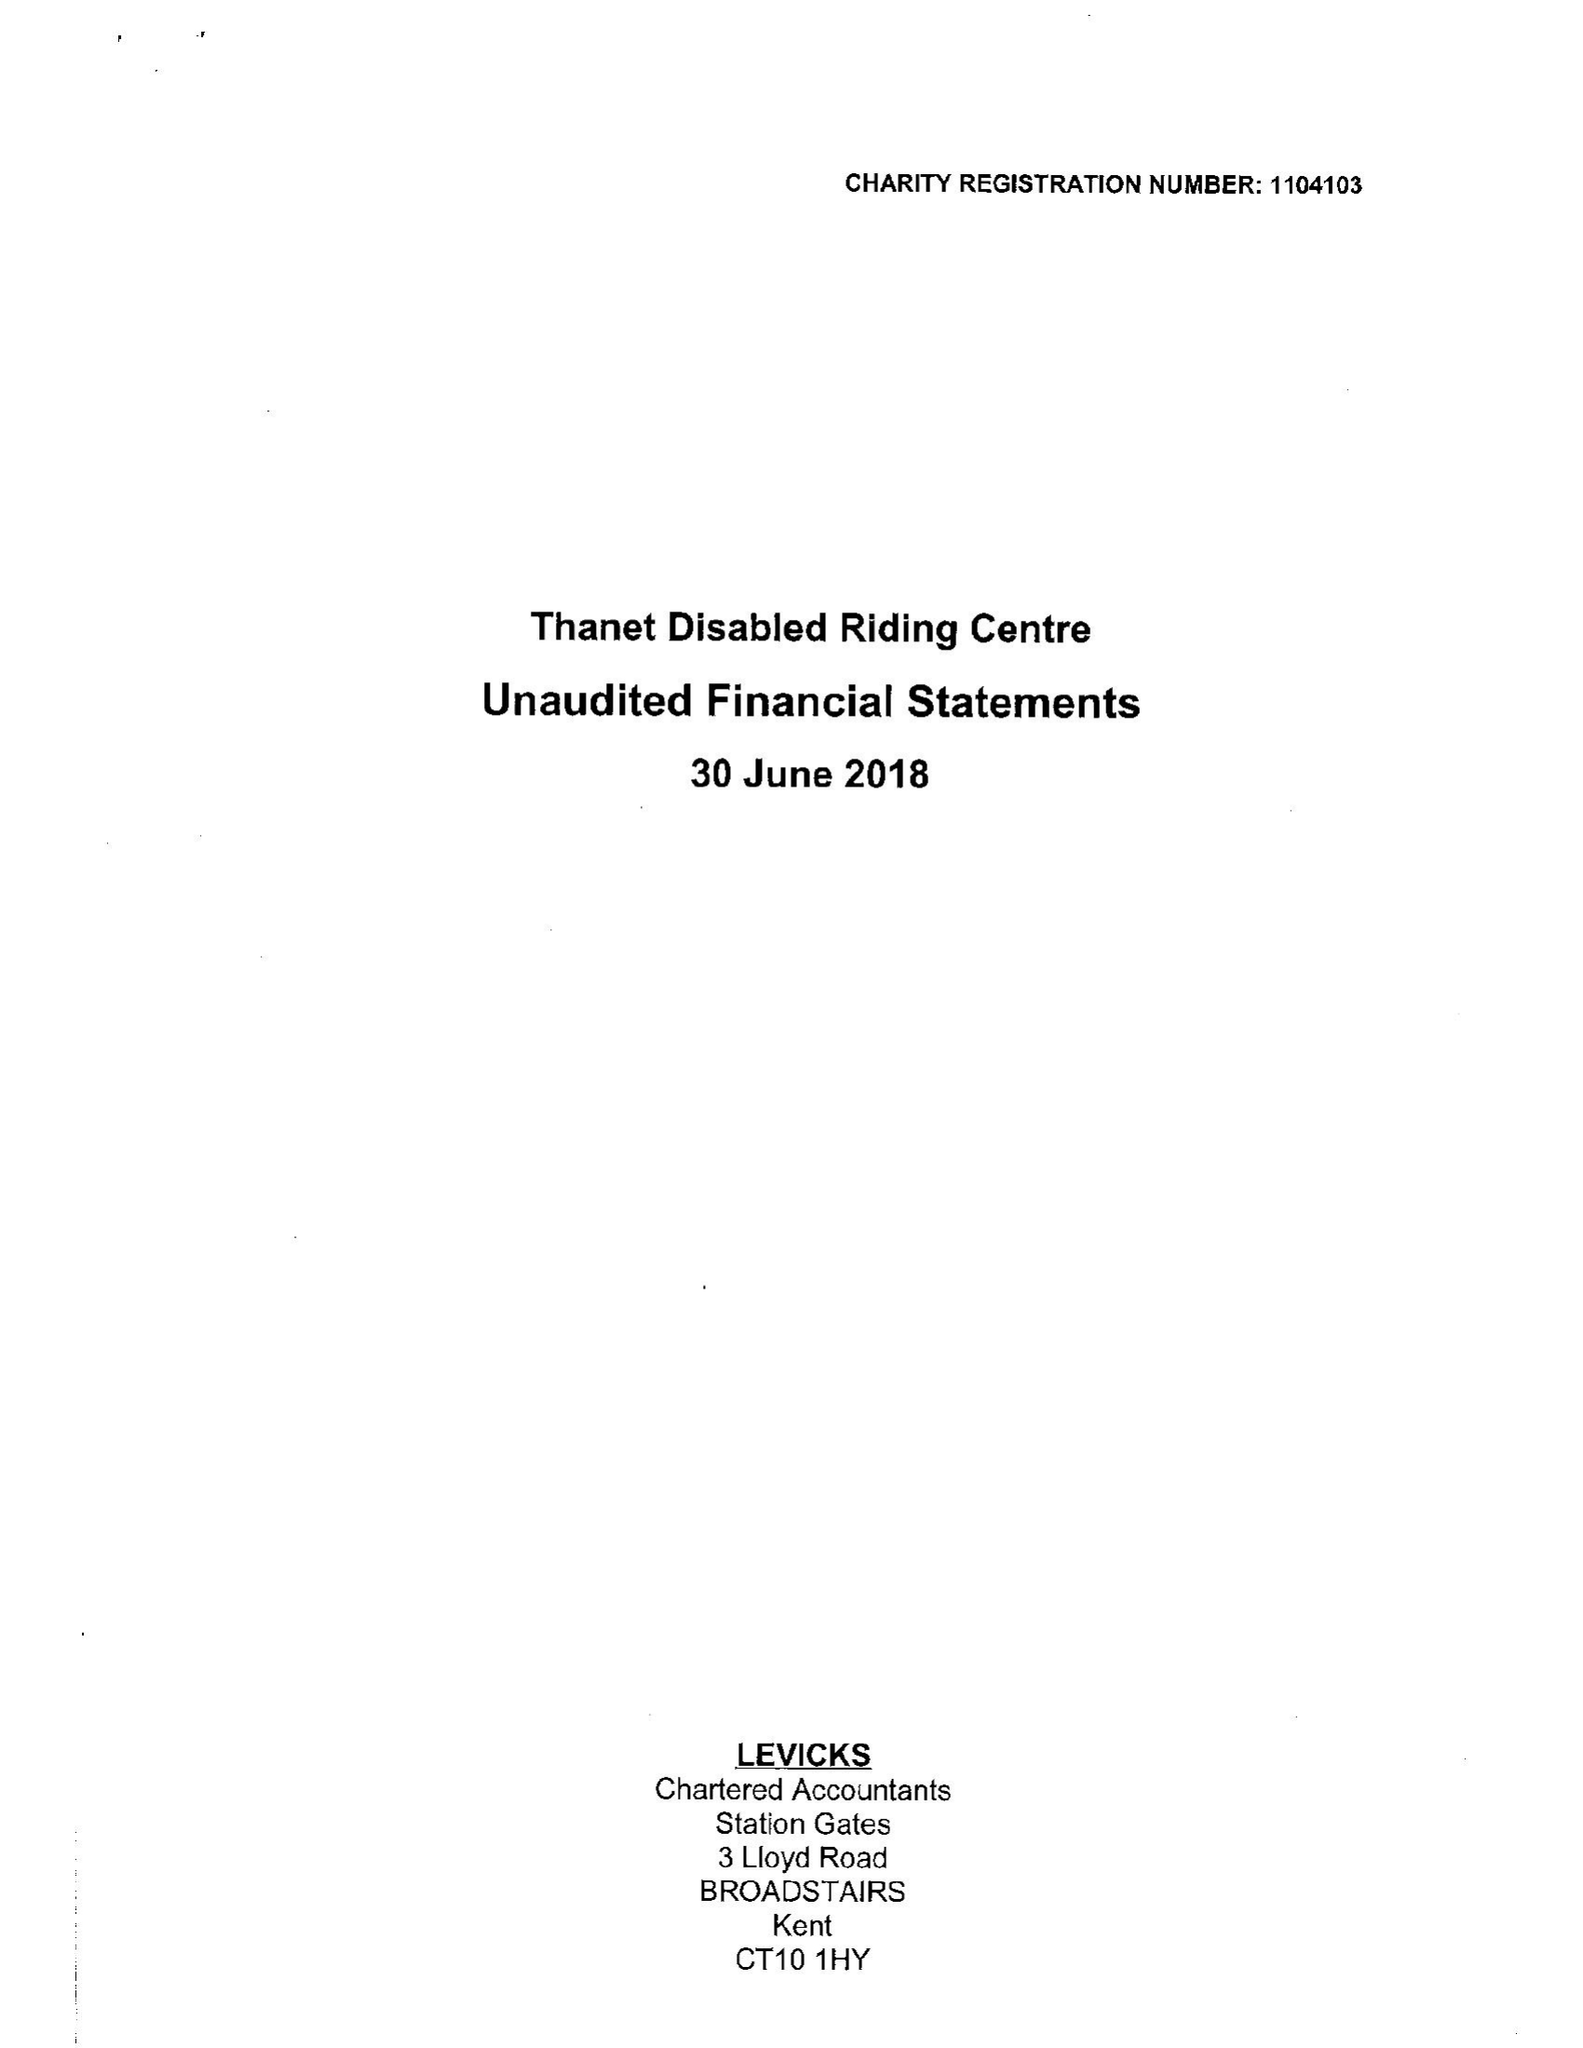What is the value for the address__post_town?
Answer the question using a single word or phrase. BROADSTAIRS 